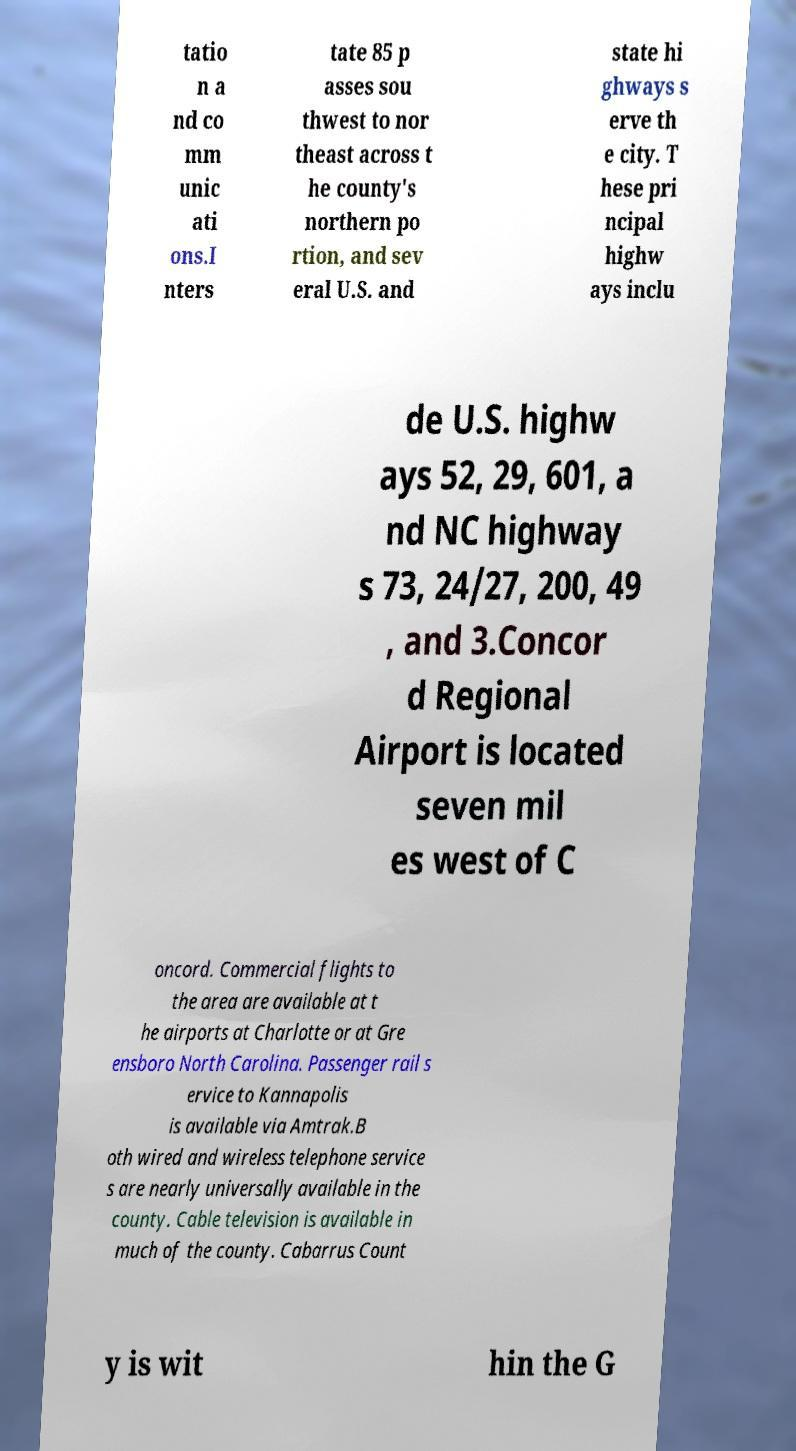For documentation purposes, I need the text within this image transcribed. Could you provide that? tatio n a nd co mm unic ati ons.I nters tate 85 p asses sou thwest to nor theast across t he county's northern po rtion, and sev eral U.S. and state hi ghways s erve th e city. T hese pri ncipal highw ays inclu de U.S. highw ays 52, 29, 601, a nd NC highway s 73, 24/27, 200, 49 , and 3.Concor d Regional Airport is located seven mil es west of C oncord. Commercial flights to the area are available at t he airports at Charlotte or at Gre ensboro North Carolina. Passenger rail s ervice to Kannapolis is available via Amtrak.B oth wired and wireless telephone service s are nearly universally available in the county. Cable television is available in much of the county. Cabarrus Count y is wit hin the G 